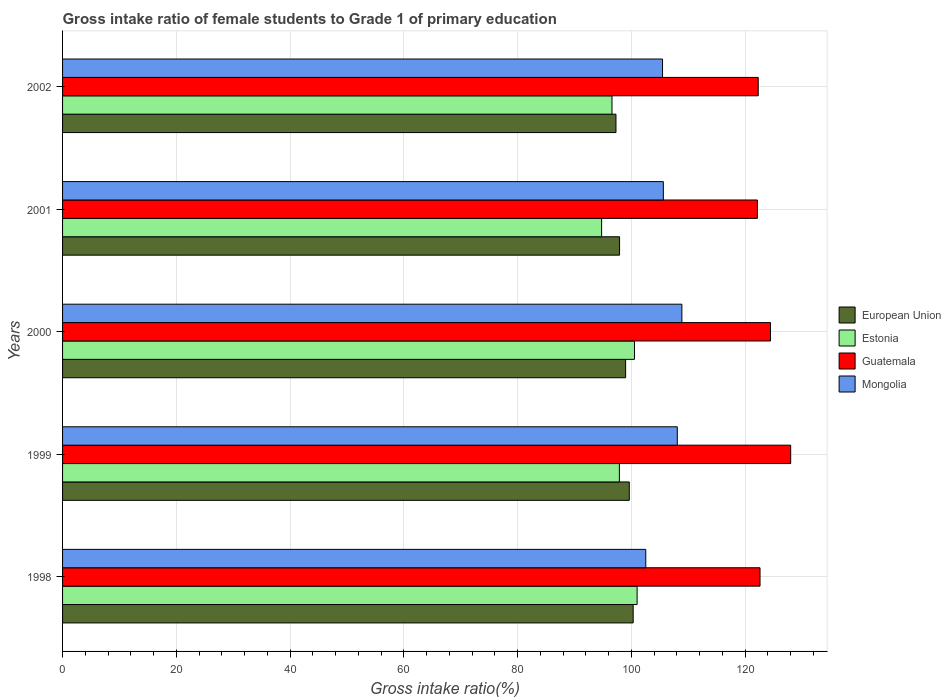Are the number of bars on each tick of the Y-axis equal?
Ensure brevity in your answer.  Yes. How many bars are there on the 3rd tick from the top?
Make the answer very short. 4. What is the label of the 2nd group of bars from the top?
Make the answer very short. 2001. What is the gross intake ratio in Mongolia in 2000?
Offer a terse response. 108.89. Across all years, what is the maximum gross intake ratio in European Union?
Your answer should be compact. 100.32. Across all years, what is the minimum gross intake ratio in Guatemala?
Offer a terse response. 122.17. What is the total gross intake ratio in Guatemala in the graph?
Give a very brief answer. 619.6. What is the difference between the gross intake ratio in Guatemala in 2001 and that in 2002?
Offer a very short reply. -0.15. What is the difference between the gross intake ratio in Estonia in 2001 and the gross intake ratio in Guatemala in 2002?
Offer a very short reply. -27.54. What is the average gross intake ratio in Guatemala per year?
Your answer should be very brief. 123.92. In the year 2001, what is the difference between the gross intake ratio in Estonia and gross intake ratio in Guatemala?
Ensure brevity in your answer.  -27.39. In how many years, is the gross intake ratio in Mongolia greater than 128 %?
Keep it short and to the point. 0. What is the ratio of the gross intake ratio in European Union in 1999 to that in 2002?
Offer a terse response. 1.02. Is the gross intake ratio in Guatemala in 1998 less than that in 2002?
Your answer should be compact. No. What is the difference between the highest and the second highest gross intake ratio in European Union?
Provide a succinct answer. 0.68. What is the difference between the highest and the lowest gross intake ratio in European Union?
Ensure brevity in your answer.  3.02. Is the sum of the gross intake ratio in Mongolia in 1999 and 2000 greater than the maximum gross intake ratio in European Union across all years?
Your response must be concise. Yes. Is it the case that in every year, the sum of the gross intake ratio in Mongolia and gross intake ratio in European Union is greater than the sum of gross intake ratio in Estonia and gross intake ratio in Guatemala?
Provide a short and direct response. No. What does the 2nd bar from the top in 2001 represents?
Offer a terse response. Guatemala. What does the 4th bar from the bottom in 1999 represents?
Provide a short and direct response. Mongolia. Is it the case that in every year, the sum of the gross intake ratio in Guatemala and gross intake ratio in European Union is greater than the gross intake ratio in Estonia?
Offer a very short reply. Yes. How many bars are there?
Your response must be concise. 20. Are all the bars in the graph horizontal?
Offer a terse response. Yes. How many years are there in the graph?
Give a very brief answer. 5. Does the graph contain any zero values?
Ensure brevity in your answer.  No. Does the graph contain grids?
Give a very brief answer. Yes. Where does the legend appear in the graph?
Provide a succinct answer. Center right. How many legend labels are there?
Your response must be concise. 4. How are the legend labels stacked?
Offer a terse response. Vertical. What is the title of the graph?
Give a very brief answer. Gross intake ratio of female students to Grade 1 of primary education. Does "OECD members" appear as one of the legend labels in the graph?
Your response must be concise. No. What is the label or title of the X-axis?
Keep it short and to the point. Gross intake ratio(%). What is the Gross intake ratio(%) in European Union in 1998?
Offer a very short reply. 100.32. What is the Gross intake ratio(%) of Estonia in 1998?
Your response must be concise. 101.02. What is the Gross intake ratio(%) in Guatemala in 1998?
Provide a succinct answer. 122.63. What is the Gross intake ratio(%) in Mongolia in 1998?
Make the answer very short. 102.54. What is the Gross intake ratio(%) in European Union in 1999?
Offer a terse response. 99.64. What is the Gross intake ratio(%) of Estonia in 1999?
Give a very brief answer. 97.9. What is the Gross intake ratio(%) in Guatemala in 1999?
Provide a short and direct response. 128.02. What is the Gross intake ratio(%) of Mongolia in 1999?
Ensure brevity in your answer.  108.08. What is the Gross intake ratio(%) in European Union in 2000?
Make the answer very short. 99. What is the Gross intake ratio(%) of Estonia in 2000?
Provide a succinct answer. 100.55. What is the Gross intake ratio(%) of Guatemala in 2000?
Offer a very short reply. 124.47. What is the Gross intake ratio(%) in Mongolia in 2000?
Your answer should be very brief. 108.89. What is the Gross intake ratio(%) of European Union in 2001?
Your answer should be very brief. 97.93. What is the Gross intake ratio(%) of Estonia in 2001?
Provide a succinct answer. 94.78. What is the Gross intake ratio(%) in Guatemala in 2001?
Your response must be concise. 122.17. What is the Gross intake ratio(%) in Mongolia in 2001?
Your response must be concise. 105.63. What is the Gross intake ratio(%) in European Union in 2002?
Your answer should be very brief. 97.3. What is the Gross intake ratio(%) of Estonia in 2002?
Offer a very short reply. 96.6. What is the Gross intake ratio(%) of Guatemala in 2002?
Offer a very short reply. 122.31. What is the Gross intake ratio(%) in Mongolia in 2002?
Offer a very short reply. 105.49. Across all years, what is the maximum Gross intake ratio(%) of European Union?
Provide a short and direct response. 100.32. Across all years, what is the maximum Gross intake ratio(%) in Estonia?
Offer a very short reply. 101.02. Across all years, what is the maximum Gross intake ratio(%) in Guatemala?
Make the answer very short. 128.02. Across all years, what is the maximum Gross intake ratio(%) in Mongolia?
Keep it short and to the point. 108.89. Across all years, what is the minimum Gross intake ratio(%) in European Union?
Ensure brevity in your answer.  97.3. Across all years, what is the minimum Gross intake ratio(%) in Estonia?
Offer a terse response. 94.78. Across all years, what is the minimum Gross intake ratio(%) in Guatemala?
Keep it short and to the point. 122.17. Across all years, what is the minimum Gross intake ratio(%) of Mongolia?
Offer a very short reply. 102.54. What is the total Gross intake ratio(%) in European Union in the graph?
Provide a short and direct response. 494.19. What is the total Gross intake ratio(%) in Estonia in the graph?
Your response must be concise. 490.85. What is the total Gross intake ratio(%) in Guatemala in the graph?
Provide a succinct answer. 619.6. What is the total Gross intake ratio(%) in Mongolia in the graph?
Offer a very short reply. 530.63. What is the difference between the Gross intake ratio(%) in European Union in 1998 and that in 1999?
Offer a terse response. 0.68. What is the difference between the Gross intake ratio(%) in Estonia in 1998 and that in 1999?
Offer a terse response. 3.12. What is the difference between the Gross intake ratio(%) in Guatemala in 1998 and that in 1999?
Keep it short and to the point. -5.39. What is the difference between the Gross intake ratio(%) of Mongolia in 1998 and that in 1999?
Give a very brief answer. -5.54. What is the difference between the Gross intake ratio(%) in European Union in 1998 and that in 2000?
Provide a succinct answer. 1.33. What is the difference between the Gross intake ratio(%) in Estonia in 1998 and that in 2000?
Offer a very short reply. 0.46. What is the difference between the Gross intake ratio(%) of Guatemala in 1998 and that in 2000?
Your answer should be very brief. -1.84. What is the difference between the Gross intake ratio(%) in Mongolia in 1998 and that in 2000?
Your response must be concise. -6.35. What is the difference between the Gross intake ratio(%) in European Union in 1998 and that in 2001?
Keep it short and to the point. 2.39. What is the difference between the Gross intake ratio(%) of Estonia in 1998 and that in 2001?
Offer a terse response. 6.24. What is the difference between the Gross intake ratio(%) of Guatemala in 1998 and that in 2001?
Keep it short and to the point. 0.46. What is the difference between the Gross intake ratio(%) of Mongolia in 1998 and that in 2001?
Provide a succinct answer. -3.09. What is the difference between the Gross intake ratio(%) of European Union in 1998 and that in 2002?
Your answer should be compact. 3.02. What is the difference between the Gross intake ratio(%) in Estonia in 1998 and that in 2002?
Provide a short and direct response. 4.42. What is the difference between the Gross intake ratio(%) in Guatemala in 1998 and that in 2002?
Offer a very short reply. 0.31. What is the difference between the Gross intake ratio(%) in Mongolia in 1998 and that in 2002?
Your response must be concise. -2.95. What is the difference between the Gross intake ratio(%) in European Union in 1999 and that in 2000?
Keep it short and to the point. 0.65. What is the difference between the Gross intake ratio(%) of Estonia in 1999 and that in 2000?
Keep it short and to the point. -2.65. What is the difference between the Gross intake ratio(%) of Guatemala in 1999 and that in 2000?
Offer a terse response. 3.55. What is the difference between the Gross intake ratio(%) in Mongolia in 1999 and that in 2000?
Your answer should be very brief. -0.8. What is the difference between the Gross intake ratio(%) of European Union in 1999 and that in 2001?
Make the answer very short. 1.71. What is the difference between the Gross intake ratio(%) of Estonia in 1999 and that in 2001?
Your answer should be compact. 3.12. What is the difference between the Gross intake ratio(%) in Guatemala in 1999 and that in 2001?
Offer a very short reply. 5.85. What is the difference between the Gross intake ratio(%) in Mongolia in 1999 and that in 2001?
Give a very brief answer. 2.45. What is the difference between the Gross intake ratio(%) of European Union in 1999 and that in 2002?
Your answer should be compact. 2.34. What is the difference between the Gross intake ratio(%) in Estonia in 1999 and that in 2002?
Your response must be concise. 1.3. What is the difference between the Gross intake ratio(%) in Guatemala in 1999 and that in 2002?
Your answer should be compact. 5.71. What is the difference between the Gross intake ratio(%) in Mongolia in 1999 and that in 2002?
Your answer should be compact. 2.6. What is the difference between the Gross intake ratio(%) in European Union in 2000 and that in 2001?
Make the answer very short. 1.06. What is the difference between the Gross intake ratio(%) in Estonia in 2000 and that in 2001?
Provide a short and direct response. 5.78. What is the difference between the Gross intake ratio(%) in Guatemala in 2000 and that in 2001?
Give a very brief answer. 2.3. What is the difference between the Gross intake ratio(%) of Mongolia in 2000 and that in 2001?
Offer a very short reply. 3.26. What is the difference between the Gross intake ratio(%) of European Union in 2000 and that in 2002?
Keep it short and to the point. 1.7. What is the difference between the Gross intake ratio(%) of Estonia in 2000 and that in 2002?
Give a very brief answer. 3.96. What is the difference between the Gross intake ratio(%) in Guatemala in 2000 and that in 2002?
Offer a very short reply. 2.15. What is the difference between the Gross intake ratio(%) of Mongolia in 2000 and that in 2002?
Your response must be concise. 3.4. What is the difference between the Gross intake ratio(%) in European Union in 2001 and that in 2002?
Make the answer very short. 0.63. What is the difference between the Gross intake ratio(%) of Estonia in 2001 and that in 2002?
Your answer should be compact. -1.82. What is the difference between the Gross intake ratio(%) in Guatemala in 2001 and that in 2002?
Offer a terse response. -0.15. What is the difference between the Gross intake ratio(%) in Mongolia in 2001 and that in 2002?
Ensure brevity in your answer.  0.14. What is the difference between the Gross intake ratio(%) of European Union in 1998 and the Gross intake ratio(%) of Estonia in 1999?
Make the answer very short. 2.42. What is the difference between the Gross intake ratio(%) of European Union in 1998 and the Gross intake ratio(%) of Guatemala in 1999?
Offer a very short reply. -27.7. What is the difference between the Gross intake ratio(%) of European Union in 1998 and the Gross intake ratio(%) of Mongolia in 1999?
Your answer should be very brief. -7.76. What is the difference between the Gross intake ratio(%) of Estonia in 1998 and the Gross intake ratio(%) of Guatemala in 1999?
Offer a terse response. -27. What is the difference between the Gross intake ratio(%) of Estonia in 1998 and the Gross intake ratio(%) of Mongolia in 1999?
Offer a terse response. -7.07. What is the difference between the Gross intake ratio(%) of Guatemala in 1998 and the Gross intake ratio(%) of Mongolia in 1999?
Provide a succinct answer. 14.54. What is the difference between the Gross intake ratio(%) in European Union in 1998 and the Gross intake ratio(%) in Estonia in 2000?
Your answer should be compact. -0.23. What is the difference between the Gross intake ratio(%) of European Union in 1998 and the Gross intake ratio(%) of Guatemala in 2000?
Offer a terse response. -24.14. What is the difference between the Gross intake ratio(%) of European Union in 1998 and the Gross intake ratio(%) of Mongolia in 2000?
Offer a very short reply. -8.56. What is the difference between the Gross intake ratio(%) of Estonia in 1998 and the Gross intake ratio(%) of Guatemala in 2000?
Your response must be concise. -23.45. What is the difference between the Gross intake ratio(%) of Estonia in 1998 and the Gross intake ratio(%) of Mongolia in 2000?
Give a very brief answer. -7.87. What is the difference between the Gross intake ratio(%) in Guatemala in 1998 and the Gross intake ratio(%) in Mongolia in 2000?
Offer a terse response. 13.74. What is the difference between the Gross intake ratio(%) of European Union in 1998 and the Gross intake ratio(%) of Estonia in 2001?
Your answer should be compact. 5.55. What is the difference between the Gross intake ratio(%) of European Union in 1998 and the Gross intake ratio(%) of Guatemala in 2001?
Offer a terse response. -21.84. What is the difference between the Gross intake ratio(%) of European Union in 1998 and the Gross intake ratio(%) of Mongolia in 2001?
Your answer should be compact. -5.31. What is the difference between the Gross intake ratio(%) in Estonia in 1998 and the Gross intake ratio(%) in Guatemala in 2001?
Provide a short and direct response. -21.15. What is the difference between the Gross intake ratio(%) of Estonia in 1998 and the Gross intake ratio(%) of Mongolia in 2001?
Your answer should be compact. -4.61. What is the difference between the Gross intake ratio(%) of Guatemala in 1998 and the Gross intake ratio(%) of Mongolia in 2001?
Keep it short and to the point. 17. What is the difference between the Gross intake ratio(%) of European Union in 1998 and the Gross intake ratio(%) of Estonia in 2002?
Keep it short and to the point. 3.72. What is the difference between the Gross intake ratio(%) of European Union in 1998 and the Gross intake ratio(%) of Guatemala in 2002?
Offer a terse response. -21.99. What is the difference between the Gross intake ratio(%) in European Union in 1998 and the Gross intake ratio(%) in Mongolia in 2002?
Your answer should be compact. -5.16. What is the difference between the Gross intake ratio(%) in Estonia in 1998 and the Gross intake ratio(%) in Guatemala in 2002?
Give a very brief answer. -21.3. What is the difference between the Gross intake ratio(%) in Estonia in 1998 and the Gross intake ratio(%) in Mongolia in 2002?
Offer a very short reply. -4.47. What is the difference between the Gross intake ratio(%) of Guatemala in 1998 and the Gross intake ratio(%) of Mongolia in 2002?
Ensure brevity in your answer.  17.14. What is the difference between the Gross intake ratio(%) of European Union in 1999 and the Gross intake ratio(%) of Estonia in 2000?
Make the answer very short. -0.91. What is the difference between the Gross intake ratio(%) in European Union in 1999 and the Gross intake ratio(%) in Guatemala in 2000?
Keep it short and to the point. -24.83. What is the difference between the Gross intake ratio(%) of European Union in 1999 and the Gross intake ratio(%) of Mongolia in 2000?
Your response must be concise. -9.24. What is the difference between the Gross intake ratio(%) of Estonia in 1999 and the Gross intake ratio(%) of Guatemala in 2000?
Give a very brief answer. -26.57. What is the difference between the Gross intake ratio(%) of Estonia in 1999 and the Gross intake ratio(%) of Mongolia in 2000?
Your response must be concise. -10.99. What is the difference between the Gross intake ratio(%) in Guatemala in 1999 and the Gross intake ratio(%) in Mongolia in 2000?
Your answer should be very brief. 19.13. What is the difference between the Gross intake ratio(%) in European Union in 1999 and the Gross intake ratio(%) in Estonia in 2001?
Your answer should be very brief. 4.87. What is the difference between the Gross intake ratio(%) in European Union in 1999 and the Gross intake ratio(%) in Guatemala in 2001?
Ensure brevity in your answer.  -22.52. What is the difference between the Gross intake ratio(%) of European Union in 1999 and the Gross intake ratio(%) of Mongolia in 2001?
Provide a short and direct response. -5.99. What is the difference between the Gross intake ratio(%) of Estonia in 1999 and the Gross intake ratio(%) of Guatemala in 2001?
Your answer should be very brief. -24.27. What is the difference between the Gross intake ratio(%) of Estonia in 1999 and the Gross intake ratio(%) of Mongolia in 2001?
Keep it short and to the point. -7.73. What is the difference between the Gross intake ratio(%) in Guatemala in 1999 and the Gross intake ratio(%) in Mongolia in 2001?
Your answer should be compact. 22.39. What is the difference between the Gross intake ratio(%) of European Union in 1999 and the Gross intake ratio(%) of Estonia in 2002?
Provide a short and direct response. 3.04. What is the difference between the Gross intake ratio(%) of European Union in 1999 and the Gross intake ratio(%) of Guatemala in 2002?
Make the answer very short. -22.67. What is the difference between the Gross intake ratio(%) of European Union in 1999 and the Gross intake ratio(%) of Mongolia in 2002?
Make the answer very short. -5.84. What is the difference between the Gross intake ratio(%) of Estonia in 1999 and the Gross intake ratio(%) of Guatemala in 2002?
Offer a very short reply. -24.41. What is the difference between the Gross intake ratio(%) in Estonia in 1999 and the Gross intake ratio(%) in Mongolia in 2002?
Your response must be concise. -7.59. What is the difference between the Gross intake ratio(%) in Guatemala in 1999 and the Gross intake ratio(%) in Mongolia in 2002?
Give a very brief answer. 22.53. What is the difference between the Gross intake ratio(%) of European Union in 2000 and the Gross intake ratio(%) of Estonia in 2001?
Make the answer very short. 4.22. What is the difference between the Gross intake ratio(%) in European Union in 2000 and the Gross intake ratio(%) in Guatemala in 2001?
Your answer should be compact. -23.17. What is the difference between the Gross intake ratio(%) in European Union in 2000 and the Gross intake ratio(%) in Mongolia in 2001?
Provide a short and direct response. -6.63. What is the difference between the Gross intake ratio(%) in Estonia in 2000 and the Gross intake ratio(%) in Guatemala in 2001?
Make the answer very short. -21.61. What is the difference between the Gross intake ratio(%) of Estonia in 2000 and the Gross intake ratio(%) of Mongolia in 2001?
Make the answer very short. -5.07. What is the difference between the Gross intake ratio(%) of Guatemala in 2000 and the Gross intake ratio(%) of Mongolia in 2001?
Your answer should be compact. 18.84. What is the difference between the Gross intake ratio(%) in European Union in 2000 and the Gross intake ratio(%) in Estonia in 2002?
Give a very brief answer. 2.4. What is the difference between the Gross intake ratio(%) of European Union in 2000 and the Gross intake ratio(%) of Guatemala in 2002?
Your response must be concise. -23.32. What is the difference between the Gross intake ratio(%) of European Union in 2000 and the Gross intake ratio(%) of Mongolia in 2002?
Your answer should be very brief. -6.49. What is the difference between the Gross intake ratio(%) of Estonia in 2000 and the Gross intake ratio(%) of Guatemala in 2002?
Offer a very short reply. -21.76. What is the difference between the Gross intake ratio(%) in Estonia in 2000 and the Gross intake ratio(%) in Mongolia in 2002?
Your answer should be very brief. -4.93. What is the difference between the Gross intake ratio(%) of Guatemala in 2000 and the Gross intake ratio(%) of Mongolia in 2002?
Provide a short and direct response. 18.98. What is the difference between the Gross intake ratio(%) of European Union in 2001 and the Gross intake ratio(%) of Estonia in 2002?
Offer a terse response. 1.33. What is the difference between the Gross intake ratio(%) in European Union in 2001 and the Gross intake ratio(%) in Guatemala in 2002?
Give a very brief answer. -24.38. What is the difference between the Gross intake ratio(%) in European Union in 2001 and the Gross intake ratio(%) in Mongolia in 2002?
Your answer should be very brief. -7.55. What is the difference between the Gross intake ratio(%) of Estonia in 2001 and the Gross intake ratio(%) of Guatemala in 2002?
Your response must be concise. -27.54. What is the difference between the Gross intake ratio(%) in Estonia in 2001 and the Gross intake ratio(%) in Mongolia in 2002?
Make the answer very short. -10.71. What is the difference between the Gross intake ratio(%) of Guatemala in 2001 and the Gross intake ratio(%) of Mongolia in 2002?
Provide a short and direct response. 16.68. What is the average Gross intake ratio(%) in European Union per year?
Offer a very short reply. 98.84. What is the average Gross intake ratio(%) of Estonia per year?
Provide a succinct answer. 98.17. What is the average Gross intake ratio(%) in Guatemala per year?
Offer a very short reply. 123.92. What is the average Gross intake ratio(%) of Mongolia per year?
Offer a very short reply. 106.13. In the year 1998, what is the difference between the Gross intake ratio(%) in European Union and Gross intake ratio(%) in Estonia?
Provide a short and direct response. -0.69. In the year 1998, what is the difference between the Gross intake ratio(%) of European Union and Gross intake ratio(%) of Guatemala?
Make the answer very short. -22.3. In the year 1998, what is the difference between the Gross intake ratio(%) in European Union and Gross intake ratio(%) in Mongolia?
Provide a succinct answer. -2.22. In the year 1998, what is the difference between the Gross intake ratio(%) in Estonia and Gross intake ratio(%) in Guatemala?
Offer a terse response. -21.61. In the year 1998, what is the difference between the Gross intake ratio(%) in Estonia and Gross intake ratio(%) in Mongolia?
Keep it short and to the point. -1.52. In the year 1998, what is the difference between the Gross intake ratio(%) in Guatemala and Gross intake ratio(%) in Mongolia?
Ensure brevity in your answer.  20.09. In the year 1999, what is the difference between the Gross intake ratio(%) in European Union and Gross intake ratio(%) in Estonia?
Provide a short and direct response. 1.74. In the year 1999, what is the difference between the Gross intake ratio(%) in European Union and Gross intake ratio(%) in Guatemala?
Your answer should be very brief. -28.38. In the year 1999, what is the difference between the Gross intake ratio(%) of European Union and Gross intake ratio(%) of Mongolia?
Offer a very short reply. -8.44. In the year 1999, what is the difference between the Gross intake ratio(%) in Estonia and Gross intake ratio(%) in Guatemala?
Ensure brevity in your answer.  -30.12. In the year 1999, what is the difference between the Gross intake ratio(%) of Estonia and Gross intake ratio(%) of Mongolia?
Keep it short and to the point. -10.18. In the year 1999, what is the difference between the Gross intake ratio(%) in Guatemala and Gross intake ratio(%) in Mongolia?
Your answer should be very brief. 19.94. In the year 2000, what is the difference between the Gross intake ratio(%) in European Union and Gross intake ratio(%) in Estonia?
Offer a very short reply. -1.56. In the year 2000, what is the difference between the Gross intake ratio(%) of European Union and Gross intake ratio(%) of Guatemala?
Your response must be concise. -25.47. In the year 2000, what is the difference between the Gross intake ratio(%) of European Union and Gross intake ratio(%) of Mongolia?
Ensure brevity in your answer.  -9.89. In the year 2000, what is the difference between the Gross intake ratio(%) in Estonia and Gross intake ratio(%) in Guatemala?
Provide a succinct answer. -23.91. In the year 2000, what is the difference between the Gross intake ratio(%) in Estonia and Gross intake ratio(%) in Mongolia?
Provide a succinct answer. -8.33. In the year 2000, what is the difference between the Gross intake ratio(%) in Guatemala and Gross intake ratio(%) in Mongolia?
Your answer should be compact. 15.58. In the year 2001, what is the difference between the Gross intake ratio(%) in European Union and Gross intake ratio(%) in Estonia?
Your response must be concise. 3.16. In the year 2001, what is the difference between the Gross intake ratio(%) of European Union and Gross intake ratio(%) of Guatemala?
Your answer should be very brief. -24.23. In the year 2001, what is the difference between the Gross intake ratio(%) of European Union and Gross intake ratio(%) of Mongolia?
Provide a short and direct response. -7.7. In the year 2001, what is the difference between the Gross intake ratio(%) in Estonia and Gross intake ratio(%) in Guatemala?
Make the answer very short. -27.39. In the year 2001, what is the difference between the Gross intake ratio(%) of Estonia and Gross intake ratio(%) of Mongolia?
Your answer should be compact. -10.85. In the year 2001, what is the difference between the Gross intake ratio(%) of Guatemala and Gross intake ratio(%) of Mongolia?
Your answer should be compact. 16.54. In the year 2002, what is the difference between the Gross intake ratio(%) of European Union and Gross intake ratio(%) of Estonia?
Your answer should be compact. 0.7. In the year 2002, what is the difference between the Gross intake ratio(%) of European Union and Gross intake ratio(%) of Guatemala?
Provide a short and direct response. -25.01. In the year 2002, what is the difference between the Gross intake ratio(%) of European Union and Gross intake ratio(%) of Mongolia?
Give a very brief answer. -8.19. In the year 2002, what is the difference between the Gross intake ratio(%) in Estonia and Gross intake ratio(%) in Guatemala?
Offer a terse response. -25.72. In the year 2002, what is the difference between the Gross intake ratio(%) of Estonia and Gross intake ratio(%) of Mongolia?
Offer a very short reply. -8.89. In the year 2002, what is the difference between the Gross intake ratio(%) of Guatemala and Gross intake ratio(%) of Mongolia?
Offer a very short reply. 16.83. What is the ratio of the Gross intake ratio(%) of European Union in 1998 to that in 1999?
Keep it short and to the point. 1.01. What is the ratio of the Gross intake ratio(%) in Estonia in 1998 to that in 1999?
Provide a short and direct response. 1.03. What is the ratio of the Gross intake ratio(%) in Guatemala in 1998 to that in 1999?
Ensure brevity in your answer.  0.96. What is the ratio of the Gross intake ratio(%) of Mongolia in 1998 to that in 1999?
Your answer should be very brief. 0.95. What is the ratio of the Gross intake ratio(%) in European Union in 1998 to that in 2000?
Provide a short and direct response. 1.01. What is the ratio of the Gross intake ratio(%) in Guatemala in 1998 to that in 2000?
Keep it short and to the point. 0.99. What is the ratio of the Gross intake ratio(%) in Mongolia in 1998 to that in 2000?
Provide a short and direct response. 0.94. What is the ratio of the Gross intake ratio(%) in European Union in 1998 to that in 2001?
Provide a short and direct response. 1.02. What is the ratio of the Gross intake ratio(%) of Estonia in 1998 to that in 2001?
Keep it short and to the point. 1.07. What is the ratio of the Gross intake ratio(%) of Guatemala in 1998 to that in 2001?
Provide a succinct answer. 1. What is the ratio of the Gross intake ratio(%) in Mongolia in 1998 to that in 2001?
Offer a terse response. 0.97. What is the ratio of the Gross intake ratio(%) of European Union in 1998 to that in 2002?
Offer a terse response. 1.03. What is the ratio of the Gross intake ratio(%) in Estonia in 1998 to that in 2002?
Your answer should be very brief. 1.05. What is the ratio of the Gross intake ratio(%) of Guatemala in 1998 to that in 2002?
Your response must be concise. 1. What is the ratio of the Gross intake ratio(%) of Mongolia in 1998 to that in 2002?
Ensure brevity in your answer.  0.97. What is the ratio of the Gross intake ratio(%) in European Union in 1999 to that in 2000?
Provide a succinct answer. 1.01. What is the ratio of the Gross intake ratio(%) in Estonia in 1999 to that in 2000?
Keep it short and to the point. 0.97. What is the ratio of the Gross intake ratio(%) of Guatemala in 1999 to that in 2000?
Your answer should be compact. 1.03. What is the ratio of the Gross intake ratio(%) of Mongolia in 1999 to that in 2000?
Provide a short and direct response. 0.99. What is the ratio of the Gross intake ratio(%) in European Union in 1999 to that in 2001?
Provide a succinct answer. 1.02. What is the ratio of the Gross intake ratio(%) in Estonia in 1999 to that in 2001?
Provide a short and direct response. 1.03. What is the ratio of the Gross intake ratio(%) in Guatemala in 1999 to that in 2001?
Ensure brevity in your answer.  1.05. What is the ratio of the Gross intake ratio(%) in Mongolia in 1999 to that in 2001?
Offer a very short reply. 1.02. What is the ratio of the Gross intake ratio(%) of European Union in 1999 to that in 2002?
Keep it short and to the point. 1.02. What is the ratio of the Gross intake ratio(%) in Estonia in 1999 to that in 2002?
Offer a very short reply. 1.01. What is the ratio of the Gross intake ratio(%) of Guatemala in 1999 to that in 2002?
Keep it short and to the point. 1.05. What is the ratio of the Gross intake ratio(%) in Mongolia in 1999 to that in 2002?
Keep it short and to the point. 1.02. What is the ratio of the Gross intake ratio(%) in European Union in 2000 to that in 2001?
Ensure brevity in your answer.  1.01. What is the ratio of the Gross intake ratio(%) in Estonia in 2000 to that in 2001?
Provide a short and direct response. 1.06. What is the ratio of the Gross intake ratio(%) in Guatemala in 2000 to that in 2001?
Offer a very short reply. 1.02. What is the ratio of the Gross intake ratio(%) in Mongolia in 2000 to that in 2001?
Provide a short and direct response. 1.03. What is the ratio of the Gross intake ratio(%) of European Union in 2000 to that in 2002?
Make the answer very short. 1.02. What is the ratio of the Gross intake ratio(%) in Estonia in 2000 to that in 2002?
Ensure brevity in your answer.  1.04. What is the ratio of the Gross intake ratio(%) in Guatemala in 2000 to that in 2002?
Keep it short and to the point. 1.02. What is the ratio of the Gross intake ratio(%) of Mongolia in 2000 to that in 2002?
Ensure brevity in your answer.  1.03. What is the ratio of the Gross intake ratio(%) of European Union in 2001 to that in 2002?
Your answer should be very brief. 1.01. What is the ratio of the Gross intake ratio(%) in Estonia in 2001 to that in 2002?
Offer a terse response. 0.98. What is the ratio of the Gross intake ratio(%) of Mongolia in 2001 to that in 2002?
Keep it short and to the point. 1. What is the difference between the highest and the second highest Gross intake ratio(%) of European Union?
Your answer should be very brief. 0.68. What is the difference between the highest and the second highest Gross intake ratio(%) in Estonia?
Provide a succinct answer. 0.46. What is the difference between the highest and the second highest Gross intake ratio(%) in Guatemala?
Keep it short and to the point. 3.55. What is the difference between the highest and the second highest Gross intake ratio(%) of Mongolia?
Provide a short and direct response. 0.8. What is the difference between the highest and the lowest Gross intake ratio(%) in European Union?
Offer a very short reply. 3.02. What is the difference between the highest and the lowest Gross intake ratio(%) in Estonia?
Give a very brief answer. 6.24. What is the difference between the highest and the lowest Gross intake ratio(%) in Guatemala?
Keep it short and to the point. 5.85. What is the difference between the highest and the lowest Gross intake ratio(%) of Mongolia?
Give a very brief answer. 6.35. 